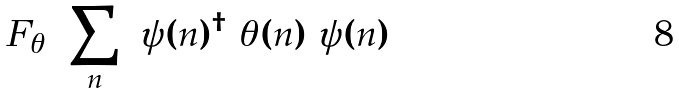Convert formula to latex. <formula><loc_0><loc_0><loc_500><loc_500>F _ { \theta } = \sum _ { n } \ \psi ( n ) ^ { \dagger } \ \theta ( n ) \ \psi ( n )</formula> 